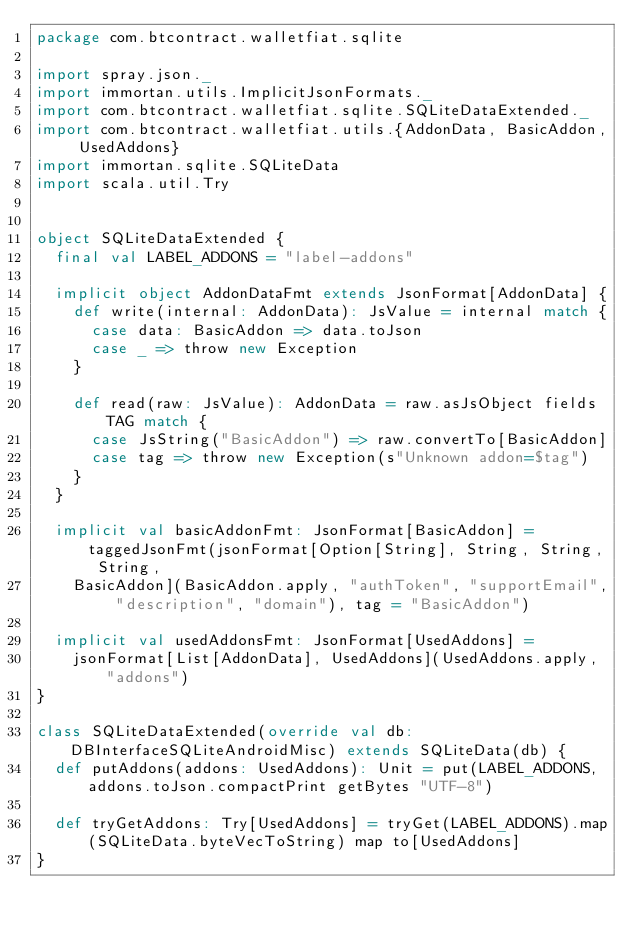<code> <loc_0><loc_0><loc_500><loc_500><_Scala_>package com.btcontract.walletfiat.sqlite

import spray.json._
import immortan.utils.ImplicitJsonFormats._
import com.btcontract.walletfiat.sqlite.SQLiteDataExtended._
import com.btcontract.walletfiat.utils.{AddonData, BasicAddon, UsedAddons}
import immortan.sqlite.SQLiteData
import scala.util.Try


object SQLiteDataExtended {
  final val LABEL_ADDONS = "label-addons"

  implicit object AddonDataFmt extends JsonFormat[AddonData] {
    def write(internal: AddonData): JsValue = internal match {
      case data: BasicAddon => data.toJson
      case _ => throw new Exception
    }

    def read(raw: JsValue): AddonData = raw.asJsObject fields TAG match {
      case JsString("BasicAddon") => raw.convertTo[BasicAddon]
      case tag => throw new Exception(s"Unknown addon=$tag")
    }
  }

  implicit val basicAddonFmt: JsonFormat[BasicAddon] = taggedJsonFmt(jsonFormat[Option[String], String, String, String,
    BasicAddon](BasicAddon.apply, "authToken", "supportEmail", "description", "domain"), tag = "BasicAddon")

  implicit val usedAddonsFmt: JsonFormat[UsedAddons] =
    jsonFormat[List[AddonData], UsedAddons](UsedAddons.apply, "addons")
}

class SQLiteDataExtended(override val db: DBInterfaceSQLiteAndroidMisc) extends SQLiteData(db) {
  def putAddons(addons: UsedAddons): Unit = put(LABEL_ADDONS, addons.toJson.compactPrint getBytes "UTF-8")

  def tryGetAddons: Try[UsedAddons] = tryGet(LABEL_ADDONS).map(SQLiteData.byteVecToString) map to[UsedAddons]
}
</code> 